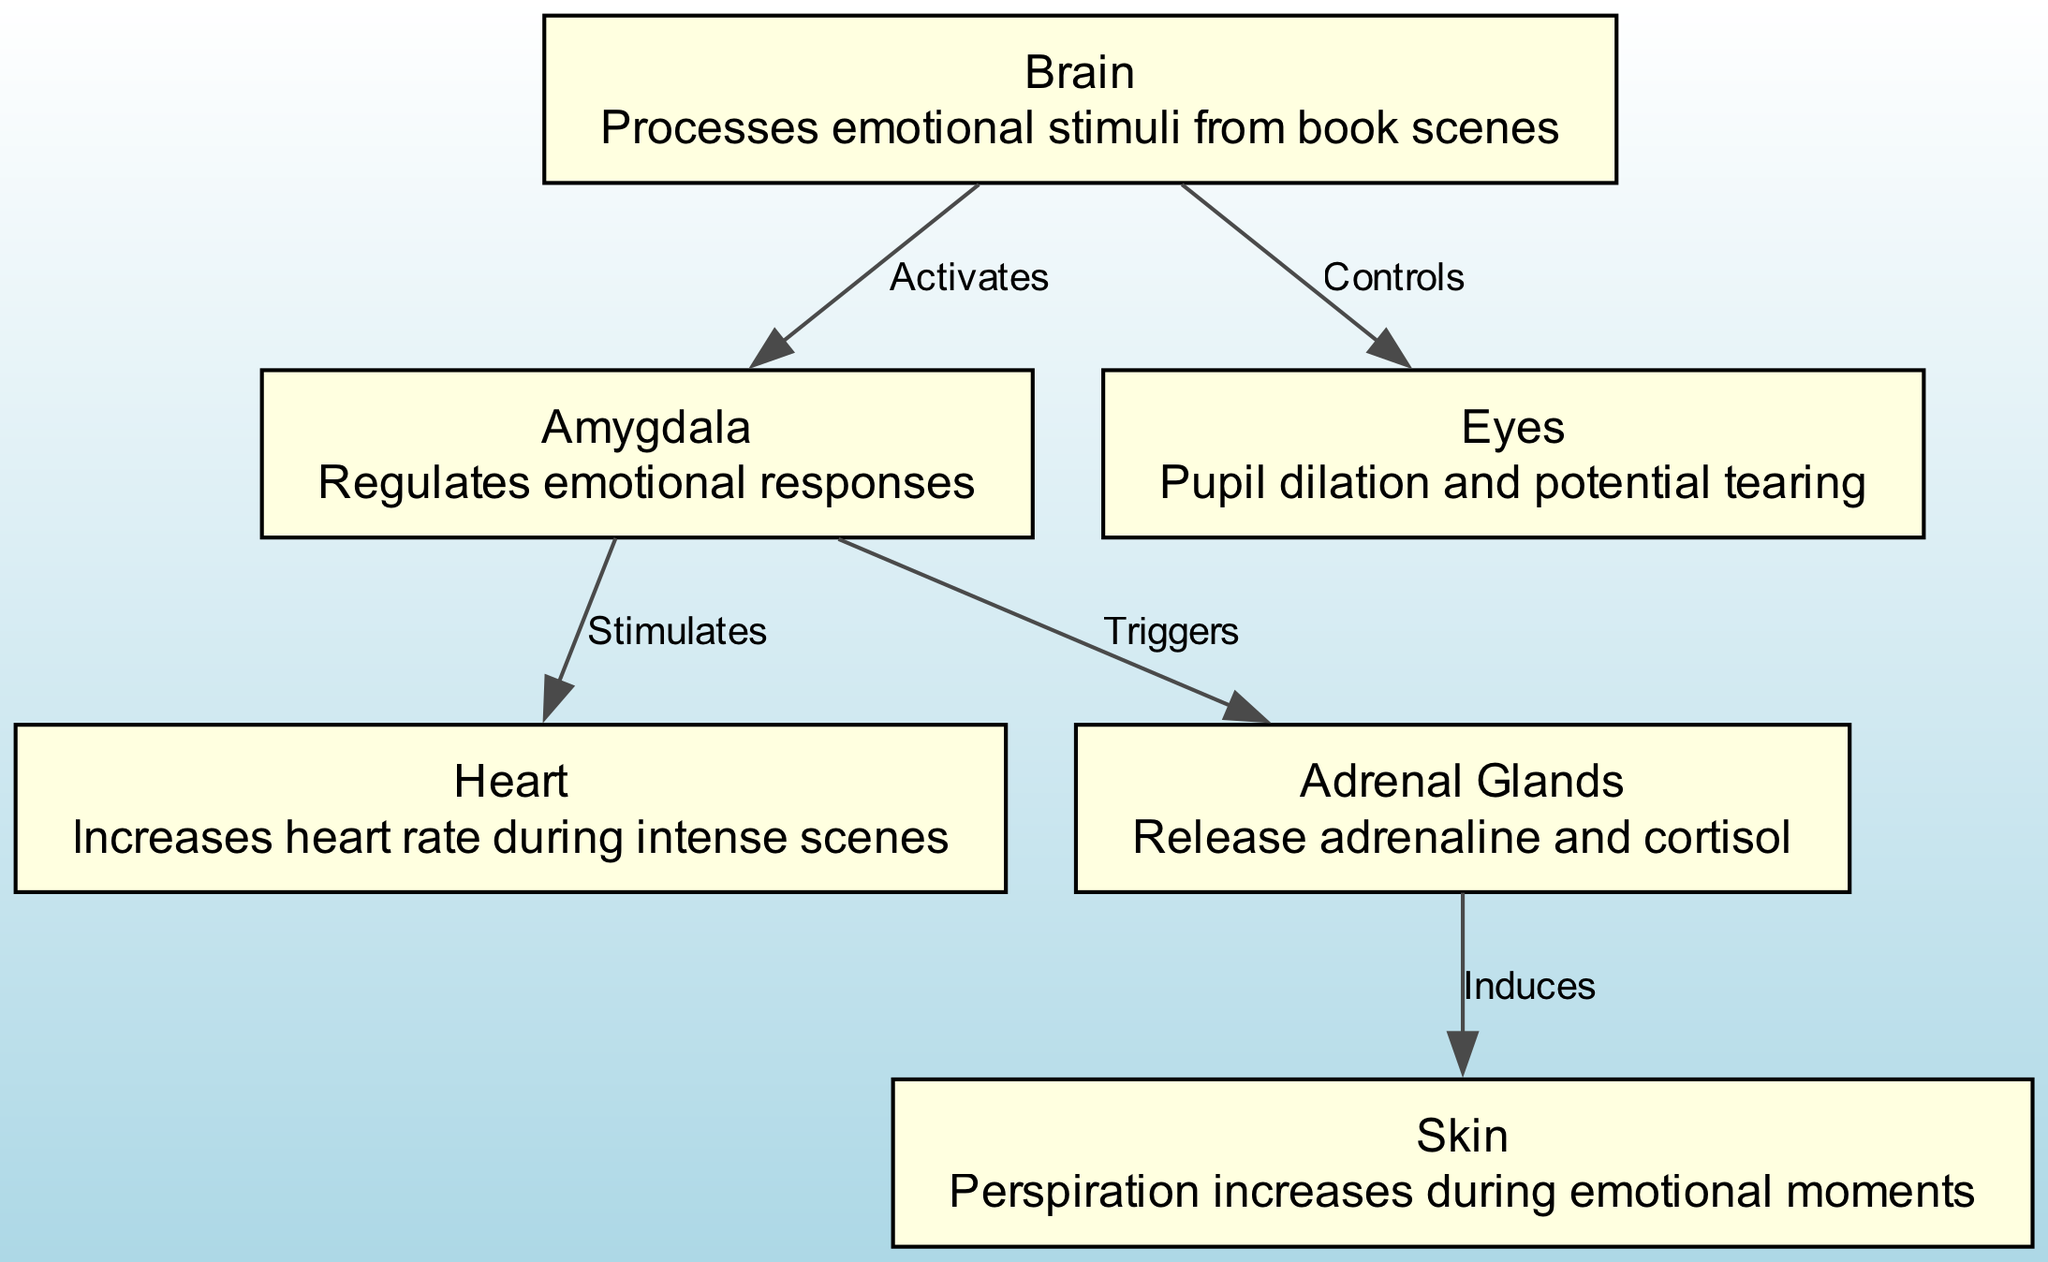What is the total number of nodes in the diagram? The diagram contains six nodes: Brain, Amygdala, Heart, Adrenal Glands, Skin, and Eyes. Thus, the total number of nodes is 6.
Answer: 6 Which node regulates emotional responses? The diagram indicates that the Amygdala is responsible for regulating emotional responses, as described in its definition.
Answer: Amygdala Which organ increases heart rate during intense scenes? According to the diagram, the Heart increases its rate during intense emotional scenes, as specified in its description.
Answer: Heart What triggers the release of adrenaline and cortisol? The edge from the Amygdala to the Adrenal Glands is labeled "Triggers," signifying that the Amygdala is responsible for triggering the release of these hormones.
Answer: Amygdala How many edges are present in the diagram? There are five edges connecting the nodes, which denote the relationships and activations among the different components represented within the diagram.
Answer: 5 Which node is responsible for perspiration increase? The diagram indicates that the Adrenal Glands induce perspiration during emotional moments, as shown in the description linked to them.
Answer: Adrenal Glands What connects the Brain to the Eyes? The connection from the Brain to the Eyes is labeled "Controls," indicating that the Brain controls the physiological response in the Eyes during intense emotional scenes.
Answer: Controls Which node provides emotional stimuli processing? The diagram states that the Brain processes emotional stimuli, making it the node responsible for this function.
Answer: Brain What is induced by the Adrenal Glands? The diagram states that the Adrenal Glands induce an increase in perspiration during emotional moments, showcasing their role during intense emotional experiences.
Answer: Perspiration 